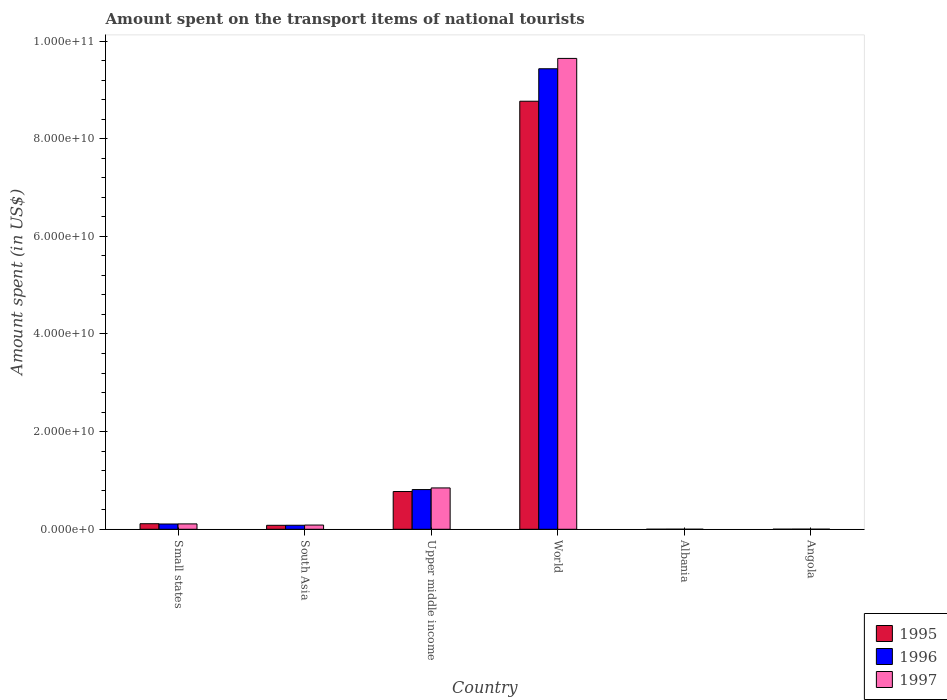How many groups of bars are there?
Your answer should be compact. 6. Are the number of bars per tick equal to the number of legend labels?
Provide a short and direct response. Yes. What is the label of the 6th group of bars from the left?
Your answer should be compact. Angola. In how many cases, is the number of bars for a given country not equal to the number of legend labels?
Keep it short and to the point. 0. What is the amount spent on the transport items of national tourists in 1995 in Angola?
Keep it short and to the point. 1.70e+07. Across all countries, what is the maximum amount spent on the transport items of national tourists in 1995?
Your answer should be very brief. 8.77e+1. Across all countries, what is the minimum amount spent on the transport items of national tourists in 1995?
Keep it short and to the point. 5.40e+06. In which country was the amount spent on the transport items of national tourists in 1997 maximum?
Keep it short and to the point. World. In which country was the amount spent on the transport items of national tourists in 1995 minimum?
Ensure brevity in your answer.  Albania. What is the total amount spent on the transport items of national tourists in 1997 in the graph?
Give a very brief answer. 1.07e+11. What is the difference between the amount spent on the transport items of national tourists in 1995 in Albania and that in Small states?
Make the answer very short. -1.13e+09. What is the difference between the amount spent on the transport items of national tourists in 1995 in Small states and the amount spent on the transport items of national tourists in 1996 in South Asia?
Offer a terse response. 3.15e+08. What is the average amount spent on the transport items of national tourists in 1997 per country?
Your answer should be very brief. 1.78e+1. What is the difference between the amount spent on the transport items of national tourists of/in 1997 and amount spent on the transport items of national tourists of/in 1996 in Upper middle income?
Give a very brief answer. 3.39e+08. What is the ratio of the amount spent on the transport items of national tourists in 1995 in South Asia to that in Upper middle income?
Offer a terse response. 0.1. Is the difference between the amount spent on the transport items of national tourists in 1997 in South Asia and World greater than the difference between the amount spent on the transport items of national tourists in 1996 in South Asia and World?
Provide a succinct answer. No. What is the difference between the highest and the second highest amount spent on the transport items of national tourists in 1997?
Provide a short and direct response. -7.37e+09. What is the difference between the highest and the lowest amount spent on the transport items of national tourists in 1995?
Offer a very short reply. 8.77e+1. Is the sum of the amount spent on the transport items of national tourists in 1995 in Angola and South Asia greater than the maximum amount spent on the transport items of national tourists in 1997 across all countries?
Your answer should be very brief. No. What does the 3rd bar from the right in Angola represents?
Give a very brief answer. 1995. How many bars are there?
Keep it short and to the point. 18. Are all the bars in the graph horizontal?
Provide a short and direct response. No. What is the difference between two consecutive major ticks on the Y-axis?
Your answer should be compact. 2.00e+1. Are the values on the major ticks of Y-axis written in scientific E-notation?
Keep it short and to the point. Yes. Does the graph contain any zero values?
Your response must be concise. No. What is the title of the graph?
Keep it short and to the point. Amount spent on the transport items of national tourists. Does "1998" appear as one of the legend labels in the graph?
Keep it short and to the point. No. What is the label or title of the Y-axis?
Offer a terse response. Amount spent (in US$). What is the Amount spent (in US$) in 1995 in Small states?
Offer a terse response. 1.14e+09. What is the Amount spent (in US$) of 1996 in Small states?
Offer a terse response. 1.08e+09. What is the Amount spent (in US$) in 1997 in Small states?
Your answer should be very brief. 1.10e+09. What is the Amount spent (in US$) of 1995 in South Asia?
Ensure brevity in your answer.  8.12e+08. What is the Amount spent (in US$) of 1996 in South Asia?
Your answer should be compact. 8.23e+08. What is the Amount spent (in US$) in 1997 in South Asia?
Your answer should be compact. 8.66e+08. What is the Amount spent (in US$) in 1995 in Upper middle income?
Your answer should be very brief. 7.73e+09. What is the Amount spent (in US$) in 1996 in Upper middle income?
Offer a terse response. 8.13e+09. What is the Amount spent (in US$) in 1997 in Upper middle income?
Give a very brief answer. 8.47e+09. What is the Amount spent (in US$) in 1995 in World?
Offer a very short reply. 8.77e+1. What is the Amount spent (in US$) in 1996 in World?
Give a very brief answer. 9.43e+1. What is the Amount spent (in US$) in 1997 in World?
Keep it short and to the point. 9.64e+1. What is the Amount spent (in US$) of 1995 in Albania?
Offer a terse response. 5.40e+06. What is the Amount spent (in US$) of 1996 in Albania?
Keep it short and to the point. 1.68e+07. What is the Amount spent (in US$) in 1997 in Albania?
Provide a short and direct response. 6.60e+06. What is the Amount spent (in US$) in 1995 in Angola?
Ensure brevity in your answer.  1.70e+07. What is the Amount spent (in US$) in 1996 in Angola?
Make the answer very short. 2.90e+07. What is the Amount spent (in US$) of 1997 in Angola?
Make the answer very short. 1.50e+07. Across all countries, what is the maximum Amount spent (in US$) in 1995?
Your answer should be compact. 8.77e+1. Across all countries, what is the maximum Amount spent (in US$) in 1996?
Ensure brevity in your answer.  9.43e+1. Across all countries, what is the maximum Amount spent (in US$) of 1997?
Keep it short and to the point. 9.64e+1. Across all countries, what is the minimum Amount spent (in US$) of 1995?
Make the answer very short. 5.40e+06. Across all countries, what is the minimum Amount spent (in US$) in 1996?
Provide a short and direct response. 1.68e+07. Across all countries, what is the minimum Amount spent (in US$) of 1997?
Your answer should be compact. 6.60e+06. What is the total Amount spent (in US$) of 1995 in the graph?
Make the answer very short. 9.74e+1. What is the total Amount spent (in US$) in 1996 in the graph?
Keep it short and to the point. 1.04e+11. What is the total Amount spent (in US$) in 1997 in the graph?
Your response must be concise. 1.07e+11. What is the difference between the Amount spent (in US$) in 1995 in Small states and that in South Asia?
Keep it short and to the point. 3.25e+08. What is the difference between the Amount spent (in US$) in 1996 in Small states and that in South Asia?
Ensure brevity in your answer.  2.60e+08. What is the difference between the Amount spent (in US$) in 1997 in Small states and that in South Asia?
Offer a terse response. 2.35e+08. What is the difference between the Amount spent (in US$) of 1995 in Small states and that in Upper middle income?
Your answer should be very brief. -6.60e+09. What is the difference between the Amount spent (in US$) in 1996 in Small states and that in Upper middle income?
Your answer should be very brief. -7.05e+09. What is the difference between the Amount spent (in US$) in 1997 in Small states and that in Upper middle income?
Offer a terse response. -7.37e+09. What is the difference between the Amount spent (in US$) in 1995 in Small states and that in World?
Ensure brevity in your answer.  -8.65e+1. What is the difference between the Amount spent (in US$) in 1996 in Small states and that in World?
Your answer should be compact. -9.32e+1. What is the difference between the Amount spent (in US$) of 1997 in Small states and that in World?
Your answer should be compact. -9.53e+1. What is the difference between the Amount spent (in US$) of 1995 in Small states and that in Albania?
Ensure brevity in your answer.  1.13e+09. What is the difference between the Amount spent (in US$) of 1996 in Small states and that in Albania?
Offer a very short reply. 1.07e+09. What is the difference between the Amount spent (in US$) of 1997 in Small states and that in Albania?
Give a very brief answer. 1.09e+09. What is the difference between the Amount spent (in US$) in 1995 in Small states and that in Angola?
Provide a succinct answer. 1.12e+09. What is the difference between the Amount spent (in US$) of 1996 in Small states and that in Angola?
Ensure brevity in your answer.  1.05e+09. What is the difference between the Amount spent (in US$) in 1997 in Small states and that in Angola?
Provide a short and direct response. 1.09e+09. What is the difference between the Amount spent (in US$) in 1995 in South Asia and that in Upper middle income?
Offer a terse response. -6.92e+09. What is the difference between the Amount spent (in US$) in 1996 in South Asia and that in Upper middle income?
Make the answer very short. -7.31e+09. What is the difference between the Amount spent (in US$) of 1997 in South Asia and that in Upper middle income?
Ensure brevity in your answer.  -7.60e+09. What is the difference between the Amount spent (in US$) of 1995 in South Asia and that in World?
Provide a succinct answer. -8.69e+1. What is the difference between the Amount spent (in US$) in 1996 in South Asia and that in World?
Provide a succinct answer. -9.35e+1. What is the difference between the Amount spent (in US$) of 1997 in South Asia and that in World?
Offer a terse response. -9.56e+1. What is the difference between the Amount spent (in US$) in 1995 in South Asia and that in Albania?
Offer a very short reply. 8.07e+08. What is the difference between the Amount spent (in US$) of 1996 in South Asia and that in Albania?
Your answer should be compact. 8.06e+08. What is the difference between the Amount spent (in US$) in 1997 in South Asia and that in Albania?
Your response must be concise. 8.59e+08. What is the difference between the Amount spent (in US$) in 1995 in South Asia and that in Angola?
Your answer should be compact. 7.95e+08. What is the difference between the Amount spent (in US$) of 1996 in South Asia and that in Angola?
Make the answer very short. 7.94e+08. What is the difference between the Amount spent (in US$) in 1997 in South Asia and that in Angola?
Offer a terse response. 8.51e+08. What is the difference between the Amount spent (in US$) in 1995 in Upper middle income and that in World?
Your response must be concise. -7.99e+1. What is the difference between the Amount spent (in US$) of 1996 in Upper middle income and that in World?
Ensure brevity in your answer.  -8.62e+1. What is the difference between the Amount spent (in US$) of 1997 in Upper middle income and that in World?
Ensure brevity in your answer.  -8.80e+1. What is the difference between the Amount spent (in US$) of 1995 in Upper middle income and that in Albania?
Give a very brief answer. 7.73e+09. What is the difference between the Amount spent (in US$) of 1996 in Upper middle income and that in Albania?
Offer a very short reply. 8.11e+09. What is the difference between the Amount spent (in US$) of 1997 in Upper middle income and that in Albania?
Ensure brevity in your answer.  8.46e+09. What is the difference between the Amount spent (in US$) in 1995 in Upper middle income and that in Angola?
Provide a succinct answer. 7.72e+09. What is the difference between the Amount spent (in US$) in 1996 in Upper middle income and that in Angola?
Offer a very short reply. 8.10e+09. What is the difference between the Amount spent (in US$) in 1997 in Upper middle income and that in Angola?
Ensure brevity in your answer.  8.45e+09. What is the difference between the Amount spent (in US$) in 1995 in World and that in Albania?
Make the answer very short. 8.77e+1. What is the difference between the Amount spent (in US$) in 1996 in World and that in Albania?
Make the answer very short. 9.43e+1. What is the difference between the Amount spent (in US$) of 1997 in World and that in Albania?
Your answer should be compact. 9.64e+1. What is the difference between the Amount spent (in US$) in 1995 in World and that in Angola?
Your answer should be very brief. 8.77e+1. What is the difference between the Amount spent (in US$) of 1996 in World and that in Angola?
Your answer should be compact. 9.43e+1. What is the difference between the Amount spent (in US$) of 1997 in World and that in Angola?
Ensure brevity in your answer.  9.64e+1. What is the difference between the Amount spent (in US$) of 1995 in Albania and that in Angola?
Provide a succinct answer. -1.16e+07. What is the difference between the Amount spent (in US$) of 1996 in Albania and that in Angola?
Provide a short and direct response. -1.22e+07. What is the difference between the Amount spent (in US$) of 1997 in Albania and that in Angola?
Offer a very short reply. -8.40e+06. What is the difference between the Amount spent (in US$) of 1995 in Small states and the Amount spent (in US$) of 1996 in South Asia?
Ensure brevity in your answer.  3.15e+08. What is the difference between the Amount spent (in US$) in 1995 in Small states and the Amount spent (in US$) in 1997 in South Asia?
Make the answer very short. 2.72e+08. What is the difference between the Amount spent (in US$) of 1996 in Small states and the Amount spent (in US$) of 1997 in South Asia?
Your response must be concise. 2.18e+08. What is the difference between the Amount spent (in US$) of 1995 in Small states and the Amount spent (in US$) of 1996 in Upper middle income?
Ensure brevity in your answer.  -6.99e+09. What is the difference between the Amount spent (in US$) in 1995 in Small states and the Amount spent (in US$) in 1997 in Upper middle income?
Offer a very short reply. -7.33e+09. What is the difference between the Amount spent (in US$) in 1996 in Small states and the Amount spent (in US$) in 1997 in Upper middle income?
Ensure brevity in your answer.  -7.39e+09. What is the difference between the Amount spent (in US$) of 1995 in Small states and the Amount spent (in US$) of 1996 in World?
Provide a short and direct response. -9.32e+1. What is the difference between the Amount spent (in US$) in 1995 in Small states and the Amount spent (in US$) in 1997 in World?
Your response must be concise. -9.53e+1. What is the difference between the Amount spent (in US$) in 1996 in Small states and the Amount spent (in US$) in 1997 in World?
Make the answer very short. -9.54e+1. What is the difference between the Amount spent (in US$) in 1995 in Small states and the Amount spent (in US$) in 1996 in Albania?
Offer a very short reply. 1.12e+09. What is the difference between the Amount spent (in US$) of 1995 in Small states and the Amount spent (in US$) of 1997 in Albania?
Offer a terse response. 1.13e+09. What is the difference between the Amount spent (in US$) of 1996 in Small states and the Amount spent (in US$) of 1997 in Albania?
Provide a short and direct response. 1.08e+09. What is the difference between the Amount spent (in US$) in 1995 in Small states and the Amount spent (in US$) in 1996 in Angola?
Your response must be concise. 1.11e+09. What is the difference between the Amount spent (in US$) in 1995 in Small states and the Amount spent (in US$) in 1997 in Angola?
Make the answer very short. 1.12e+09. What is the difference between the Amount spent (in US$) in 1996 in Small states and the Amount spent (in US$) in 1997 in Angola?
Your answer should be compact. 1.07e+09. What is the difference between the Amount spent (in US$) in 1995 in South Asia and the Amount spent (in US$) in 1996 in Upper middle income?
Ensure brevity in your answer.  -7.32e+09. What is the difference between the Amount spent (in US$) of 1995 in South Asia and the Amount spent (in US$) of 1997 in Upper middle income?
Your response must be concise. -7.66e+09. What is the difference between the Amount spent (in US$) in 1996 in South Asia and the Amount spent (in US$) in 1997 in Upper middle income?
Offer a very short reply. -7.65e+09. What is the difference between the Amount spent (in US$) of 1995 in South Asia and the Amount spent (in US$) of 1996 in World?
Your answer should be very brief. -9.35e+1. What is the difference between the Amount spent (in US$) of 1995 in South Asia and the Amount spent (in US$) of 1997 in World?
Your response must be concise. -9.56e+1. What is the difference between the Amount spent (in US$) in 1996 in South Asia and the Amount spent (in US$) in 1997 in World?
Give a very brief answer. -9.56e+1. What is the difference between the Amount spent (in US$) in 1995 in South Asia and the Amount spent (in US$) in 1996 in Albania?
Keep it short and to the point. 7.95e+08. What is the difference between the Amount spent (in US$) in 1995 in South Asia and the Amount spent (in US$) in 1997 in Albania?
Your answer should be very brief. 8.05e+08. What is the difference between the Amount spent (in US$) in 1996 in South Asia and the Amount spent (in US$) in 1997 in Albania?
Keep it short and to the point. 8.16e+08. What is the difference between the Amount spent (in US$) in 1995 in South Asia and the Amount spent (in US$) in 1996 in Angola?
Your answer should be compact. 7.83e+08. What is the difference between the Amount spent (in US$) in 1995 in South Asia and the Amount spent (in US$) in 1997 in Angola?
Ensure brevity in your answer.  7.97e+08. What is the difference between the Amount spent (in US$) of 1996 in South Asia and the Amount spent (in US$) of 1997 in Angola?
Offer a terse response. 8.08e+08. What is the difference between the Amount spent (in US$) of 1995 in Upper middle income and the Amount spent (in US$) of 1996 in World?
Make the answer very short. -8.66e+1. What is the difference between the Amount spent (in US$) in 1995 in Upper middle income and the Amount spent (in US$) in 1997 in World?
Your answer should be very brief. -8.87e+1. What is the difference between the Amount spent (in US$) of 1996 in Upper middle income and the Amount spent (in US$) of 1997 in World?
Make the answer very short. -8.83e+1. What is the difference between the Amount spent (in US$) of 1995 in Upper middle income and the Amount spent (in US$) of 1996 in Albania?
Offer a terse response. 7.72e+09. What is the difference between the Amount spent (in US$) in 1995 in Upper middle income and the Amount spent (in US$) in 1997 in Albania?
Provide a succinct answer. 7.73e+09. What is the difference between the Amount spent (in US$) in 1996 in Upper middle income and the Amount spent (in US$) in 1997 in Albania?
Give a very brief answer. 8.12e+09. What is the difference between the Amount spent (in US$) in 1995 in Upper middle income and the Amount spent (in US$) in 1996 in Angola?
Your answer should be very brief. 7.70e+09. What is the difference between the Amount spent (in US$) in 1995 in Upper middle income and the Amount spent (in US$) in 1997 in Angola?
Offer a terse response. 7.72e+09. What is the difference between the Amount spent (in US$) in 1996 in Upper middle income and the Amount spent (in US$) in 1997 in Angola?
Provide a short and direct response. 8.12e+09. What is the difference between the Amount spent (in US$) of 1995 in World and the Amount spent (in US$) of 1996 in Albania?
Provide a short and direct response. 8.77e+1. What is the difference between the Amount spent (in US$) of 1995 in World and the Amount spent (in US$) of 1997 in Albania?
Your answer should be compact. 8.77e+1. What is the difference between the Amount spent (in US$) of 1996 in World and the Amount spent (in US$) of 1997 in Albania?
Ensure brevity in your answer.  9.43e+1. What is the difference between the Amount spent (in US$) of 1995 in World and the Amount spent (in US$) of 1996 in Angola?
Offer a very short reply. 8.76e+1. What is the difference between the Amount spent (in US$) of 1995 in World and the Amount spent (in US$) of 1997 in Angola?
Provide a short and direct response. 8.77e+1. What is the difference between the Amount spent (in US$) in 1996 in World and the Amount spent (in US$) in 1997 in Angola?
Offer a very short reply. 9.43e+1. What is the difference between the Amount spent (in US$) of 1995 in Albania and the Amount spent (in US$) of 1996 in Angola?
Give a very brief answer. -2.36e+07. What is the difference between the Amount spent (in US$) in 1995 in Albania and the Amount spent (in US$) in 1997 in Angola?
Ensure brevity in your answer.  -9.60e+06. What is the difference between the Amount spent (in US$) in 1996 in Albania and the Amount spent (in US$) in 1997 in Angola?
Keep it short and to the point. 1.80e+06. What is the average Amount spent (in US$) of 1995 per country?
Your answer should be very brief. 1.62e+1. What is the average Amount spent (in US$) of 1996 per country?
Make the answer very short. 1.74e+1. What is the average Amount spent (in US$) in 1997 per country?
Offer a terse response. 1.78e+1. What is the difference between the Amount spent (in US$) of 1995 and Amount spent (in US$) of 1996 in Small states?
Offer a very short reply. 5.44e+07. What is the difference between the Amount spent (in US$) in 1995 and Amount spent (in US$) in 1997 in Small states?
Your answer should be very brief. 3.69e+07. What is the difference between the Amount spent (in US$) of 1996 and Amount spent (in US$) of 1997 in Small states?
Keep it short and to the point. -1.75e+07. What is the difference between the Amount spent (in US$) in 1995 and Amount spent (in US$) in 1996 in South Asia?
Offer a terse response. -1.09e+07. What is the difference between the Amount spent (in US$) of 1995 and Amount spent (in US$) of 1997 in South Asia?
Provide a short and direct response. -5.35e+07. What is the difference between the Amount spent (in US$) of 1996 and Amount spent (in US$) of 1997 in South Asia?
Your response must be concise. -4.25e+07. What is the difference between the Amount spent (in US$) of 1995 and Amount spent (in US$) of 1996 in Upper middle income?
Your answer should be compact. -3.97e+08. What is the difference between the Amount spent (in US$) in 1995 and Amount spent (in US$) in 1997 in Upper middle income?
Keep it short and to the point. -7.36e+08. What is the difference between the Amount spent (in US$) of 1996 and Amount spent (in US$) of 1997 in Upper middle income?
Provide a succinct answer. -3.39e+08. What is the difference between the Amount spent (in US$) of 1995 and Amount spent (in US$) of 1996 in World?
Your answer should be compact. -6.65e+09. What is the difference between the Amount spent (in US$) in 1995 and Amount spent (in US$) in 1997 in World?
Give a very brief answer. -8.77e+09. What is the difference between the Amount spent (in US$) in 1996 and Amount spent (in US$) in 1997 in World?
Give a very brief answer. -2.12e+09. What is the difference between the Amount spent (in US$) of 1995 and Amount spent (in US$) of 1996 in Albania?
Keep it short and to the point. -1.14e+07. What is the difference between the Amount spent (in US$) of 1995 and Amount spent (in US$) of 1997 in Albania?
Your response must be concise. -1.20e+06. What is the difference between the Amount spent (in US$) of 1996 and Amount spent (in US$) of 1997 in Albania?
Make the answer very short. 1.02e+07. What is the difference between the Amount spent (in US$) of 1995 and Amount spent (in US$) of 1996 in Angola?
Provide a succinct answer. -1.20e+07. What is the difference between the Amount spent (in US$) of 1995 and Amount spent (in US$) of 1997 in Angola?
Offer a terse response. 2.00e+06. What is the difference between the Amount spent (in US$) of 1996 and Amount spent (in US$) of 1997 in Angola?
Give a very brief answer. 1.40e+07. What is the ratio of the Amount spent (in US$) in 1995 in Small states to that in South Asia?
Your answer should be very brief. 1.4. What is the ratio of the Amount spent (in US$) in 1996 in Small states to that in South Asia?
Your answer should be very brief. 1.32. What is the ratio of the Amount spent (in US$) of 1997 in Small states to that in South Asia?
Offer a terse response. 1.27. What is the ratio of the Amount spent (in US$) of 1995 in Small states to that in Upper middle income?
Offer a terse response. 0.15. What is the ratio of the Amount spent (in US$) of 1996 in Small states to that in Upper middle income?
Offer a very short reply. 0.13. What is the ratio of the Amount spent (in US$) of 1997 in Small states to that in Upper middle income?
Your answer should be compact. 0.13. What is the ratio of the Amount spent (in US$) of 1995 in Small states to that in World?
Give a very brief answer. 0.01. What is the ratio of the Amount spent (in US$) in 1996 in Small states to that in World?
Offer a terse response. 0.01. What is the ratio of the Amount spent (in US$) in 1997 in Small states to that in World?
Offer a terse response. 0.01. What is the ratio of the Amount spent (in US$) in 1995 in Small states to that in Albania?
Give a very brief answer. 210.65. What is the ratio of the Amount spent (in US$) of 1996 in Small states to that in Albania?
Offer a terse response. 64.47. What is the ratio of the Amount spent (in US$) of 1997 in Small states to that in Albania?
Provide a short and direct response. 166.76. What is the ratio of the Amount spent (in US$) in 1995 in Small states to that in Angola?
Offer a terse response. 66.91. What is the ratio of the Amount spent (in US$) of 1996 in Small states to that in Angola?
Your response must be concise. 37.35. What is the ratio of the Amount spent (in US$) of 1997 in Small states to that in Angola?
Your answer should be very brief. 73.37. What is the ratio of the Amount spent (in US$) in 1995 in South Asia to that in Upper middle income?
Your answer should be very brief. 0.1. What is the ratio of the Amount spent (in US$) of 1996 in South Asia to that in Upper middle income?
Your answer should be very brief. 0.1. What is the ratio of the Amount spent (in US$) in 1997 in South Asia to that in Upper middle income?
Make the answer very short. 0.1. What is the ratio of the Amount spent (in US$) of 1995 in South Asia to that in World?
Ensure brevity in your answer.  0.01. What is the ratio of the Amount spent (in US$) in 1996 in South Asia to that in World?
Ensure brevity in your answer.  0.01. What is the ratio of the Amount spent (in US$) in 1997 in South Asia to that in World?
Keep it short and to the point. 0.01. What is the ratio of the Amount spent (in US$) in 1995 in South Asia to that in Albania?
Keep it short and to the point. 150.38. What is the ratio of the Amount spent (in US$) in 1996 in South Asia to that in Albania?
Make the answer very short. 48.99. What is the ratio of the Amount spent (in US$) in 1997 in South Asia to that in Albania?
Ensure brevity in your answer.  131.14. What is the ratio of the Amount spent (in US$) in 1995 in South Asia to that in Angola?
Your answer should be compact. 47.77. What is the ratio of the Amount spent (in US$) of 1996 in South Asia to that in Angola?
Make the answer very short. 28.38. What is the ratio of the Amount spent (in US$) of 1997 in South Asia to that in Angola?
Offer a terse response. 57.7. What is the ratio of the Amount spent (in US$) of 1995 in Upper middle income to that in World?
Provide a short and direct response. 0.09. What is the ratio of the Amount spent (in US$) in 1996 in Upper middle income to that in World?
Your answer should be compact. 0.09. What is the ratio of the Amount spent (in US$) of 1997 in Upper middle income to that in World?
Offer a terse response. 0.09. What is the ratio of the Amount spent (in US$) of 1995 in Upper middle income to that in Albania?
Provide a short and direct response. 1432.19. What is the ratio of the Amount spent (in US$) in 1996 in Upper middle income to that in Albania?
Offer a very short reply. 483.97. What is the ratio of the Amount spent (in US$) in 1997 in Upper middle income to that in Albania?
Give a very brief answer. 1283.31. What is the ratio of the Amount spent (in US$) in 1995 in Upper middle income to that in Angola?
Provide a succinct answer. 454.93. What is the ratio of the Amount spent (in US$) in 1996 in Upper middle income to that in Angola?
Give a very brief answer. 280.37. What is the ratio of the Amount spent (in US$) in 1997 in Upper middle income to that in Angola?
Your answer should be compact. 564.66. What is the ratio of the Amount spent (in US$) in 1995 in World to that in Albania?
Your answer should be compact. 1.62e+04. What is the ratio of the Amount spent (in US$) of 1996 in World to that in Albania?
Your response must be concise. 5614.52. What is the ratio of the Amount spent (in US$) in 1997 in World to that in Albania?
Keep it short and to the point. 1.46e+04. What is the ratio of the Amount spent (in US$) in 1995 in World to that in Angola?
Offer a terse response. 5157.3. What is the ratio of the Amount spent (in US$) of 1996 in World to that in Angola?
Offer a terse response. 3252.55. What is the ratio of the Amount spent (in US$) in 1997 in World to that in Angola?
Ensure brevity in your answer.  6429.47. What is the ratio of the Amount spent (in US$) in 1995 in Albania to that in Angola?
Offer a terse response. 0.32. What is the ratio of the Amount spent (in US$) of 1996 in Albania to that in Angola?
Offer a terse response. 0.58. What is the ratio of the Amount spent (in US$) in 1997 in Albania to that in Angola?
Your answer should be compact. 0.44. What is the difference between the highest and the second highest Amount spent (in US$) of 1995?
Your response must be concise. 7.99e+1. What is the difference between the highest and the second highest Amount spent (in US$) of 1996?
Provide a succinct answer. 8.62e+1. What is the difference between the highest and the second highest Amount spent (in US$) of 1997?
Provide a short and direct response. 8.80e+1. What is the difference between the highest and the lowest Amount spent (in US$) of 1995?
Make the answer very short. 8.77e+1. What is the difference between the highest and the lowest Amount spent (in US$) of 1996?
Your answer should be very brief. 9.43e+1. What is the difference between the highest and the lowest Amount spent (in US$) of 1997?
Provide a succinct answer. 9.64e+1. 